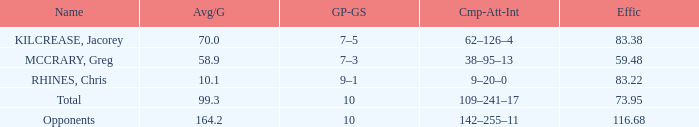Parse the full table. {'header': ['Name', 'Avg/G', 'GP-GS', 'Cmp-Att-Int', 'Effic'], 'rows': [['KILCREASE, Jacorey', '70.0', '7–5', '62–126–4', '83.38'], ['MCCRARY, Greg', '58.9', '7–3', '38–95–13', '59.48'], ['RHINES, Chris', '10.1', '9–1', '9–20–0', '83.22'], ['Total', '99.3', '10', '109–241–17', '73.95'], ['Opponents', '164.2', '10', '142–255–11', '116.68']]} What is the total avg/g of McCrary, Greg? 1.0. 